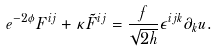<formula> <loc_0><loc_0><loc_500><loc_500>e ^ { - 2 \phi } F ^ { i j } + \kappa \tilde { F } ^ { i j } = \frac { f } { \sqrt { 2 h } } \epsilon ^ { i j k } \partial _ { k } u .</formula> 